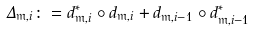<formula> <loc_0><loc_0><loc_500><loc_500>\Delta _ { \mathfrak { m } , i } \colon = d _ { \mathfrak { m } , i } ^ { * } \circ d _ { \mathfrak { m } , i } + d _ { \mathfrak { m } , i - 1 } \circ d _ { \mathfrak { m } , i - 1 } ^ { * }</formula> 